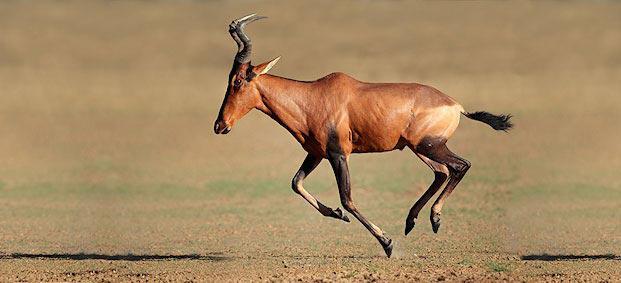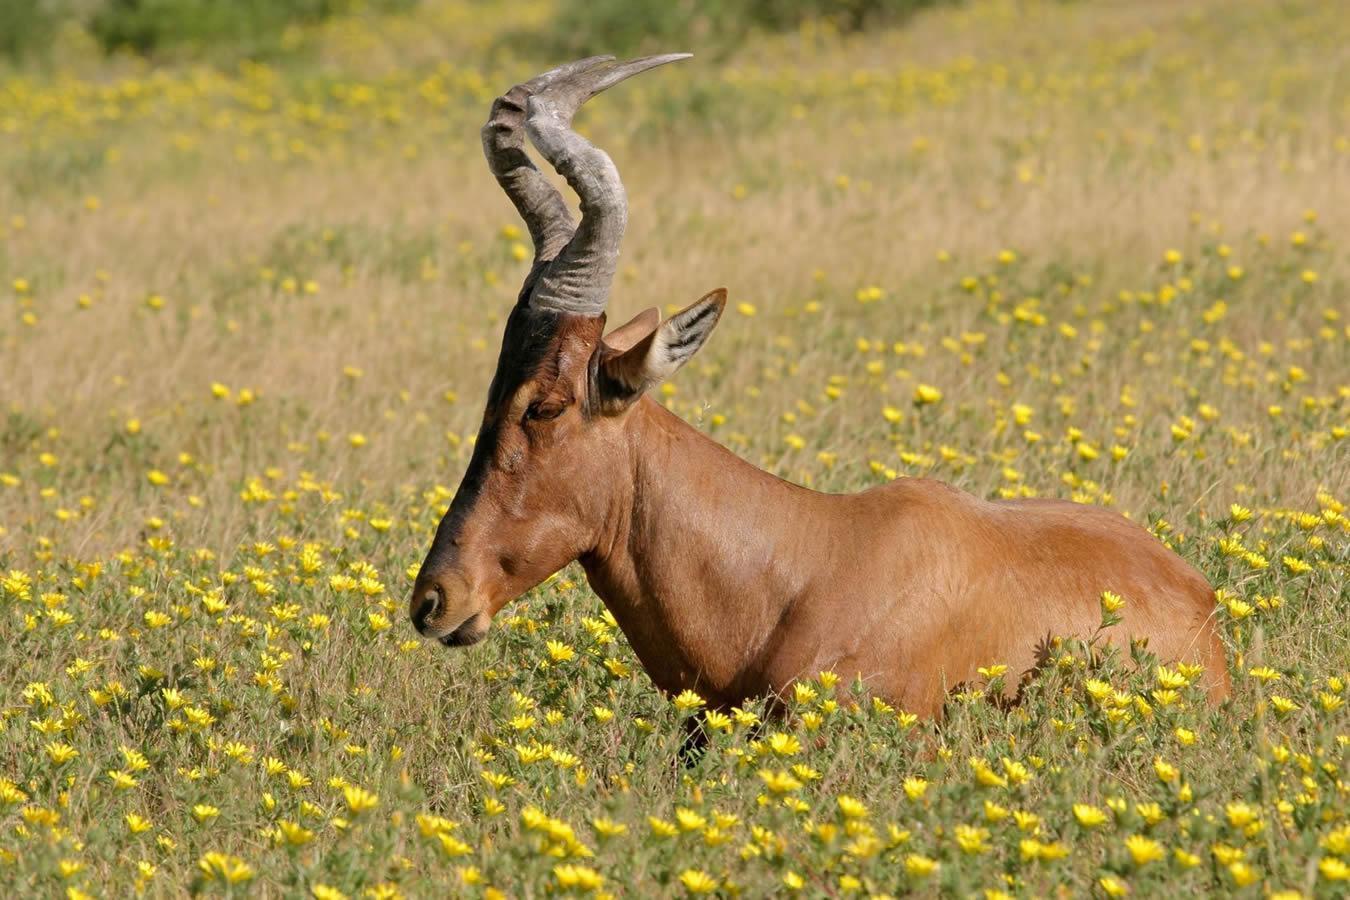The first image is the image on the left, the second image is the image on the right. For the images displayed, is the sentence "The animal in the image on the right is lying down." factually correct? Answer yes or no. Yes. 